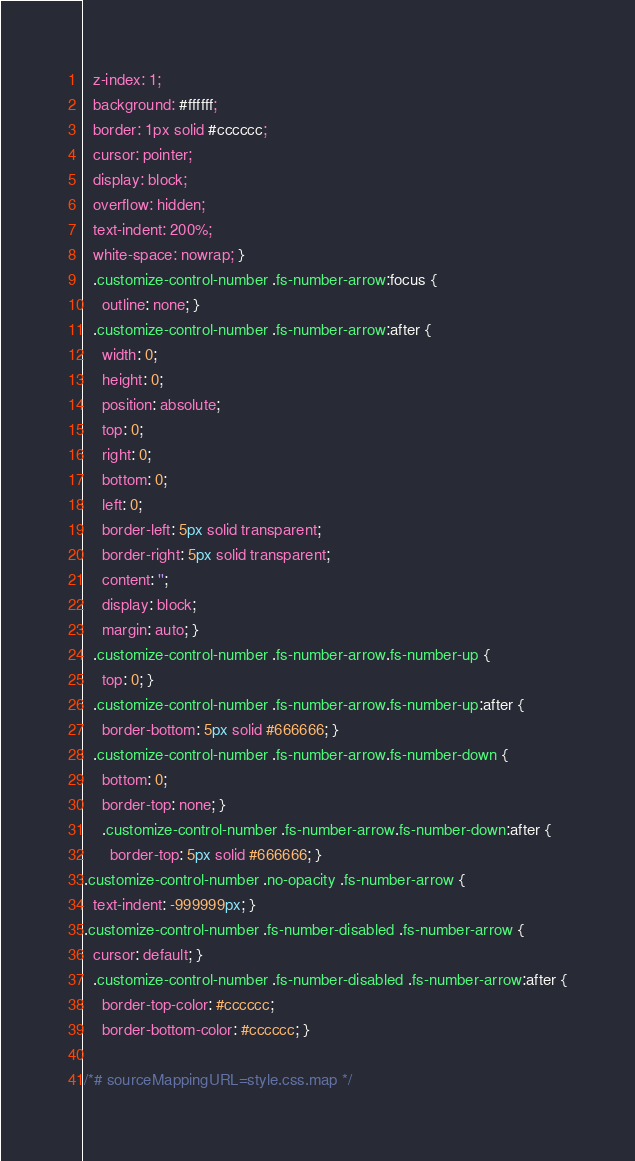Convert code to text. <code><loc_0><loc_0><loc_500><loc_500><_CSS_>  z-index: 1;
  background: #ffffff;
  border: 1px solid #cccccc;
  cursor: pointer;
  display: block;
  overflow: hidden;
  text-indent: 200%;
  white-space: nowrap; }
  .customize-control-number .fs-number-arrow:focus {
    outline: none; }
  .customize-control-number .fs-number-arrow:after {
    width: 0;
    height: 0;
    position: absolute;
    top: 0;
    right: 0;
    bottom: 0;
    left: 0;
    border-left: 5px solid transparent;
    border-right: 5px solid transparent;
    content: '';
    display: block;
    margin: auto; }
  .customize-control-number .fs-number-arrow.fs-number-up {
    top: 0; }
  .customize-control-number .fs-number-arrow.fs-number-up:after {
    border-bottom: 5px solid #666666; }
  .customize-control-number .fs-number-arrow.fs-number-down {
    bottom: 0;
    border-top: none; }
    .customize-control-number .fs-number-arrow.fs-number-down:after {
      border-top: 5px solid #666666; }
.customize-control-number .no-opacity .fs-number-arrow {
  text-indent: -999999px; }
.customize-control-number .fs-number-disabled .fs-number-arrow {
  cursor: default; }
  .customize-control-number .fs-number-disabled .fs-number-arrow:after {
    border-top-color: #cccccc;
    border-bottom-color: #cccccc; }

/*# sourceMappingURL=style.css.map */
</code> 